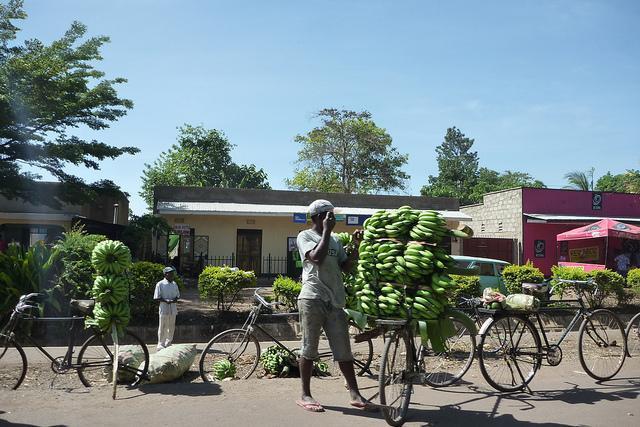How many bicycles are there?
Give a very brief answer. 4. How many chairs are in this shot?
Give a very brief answer. 0. 